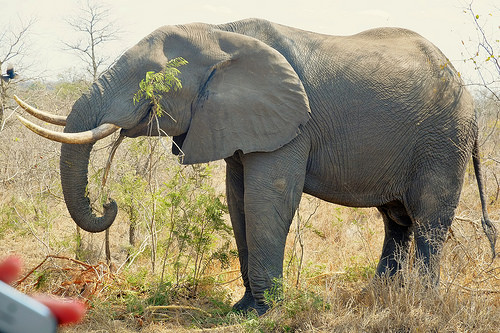<image>
Is the elephant on the grass? Yes. Looking at the image, I can see the elephant is positioned on top of the grass, with the grass providing support. Is the elephant to the right of the trees? Yes. From this viewpoint, the elephant is positioned to the right side relative to the trees. 